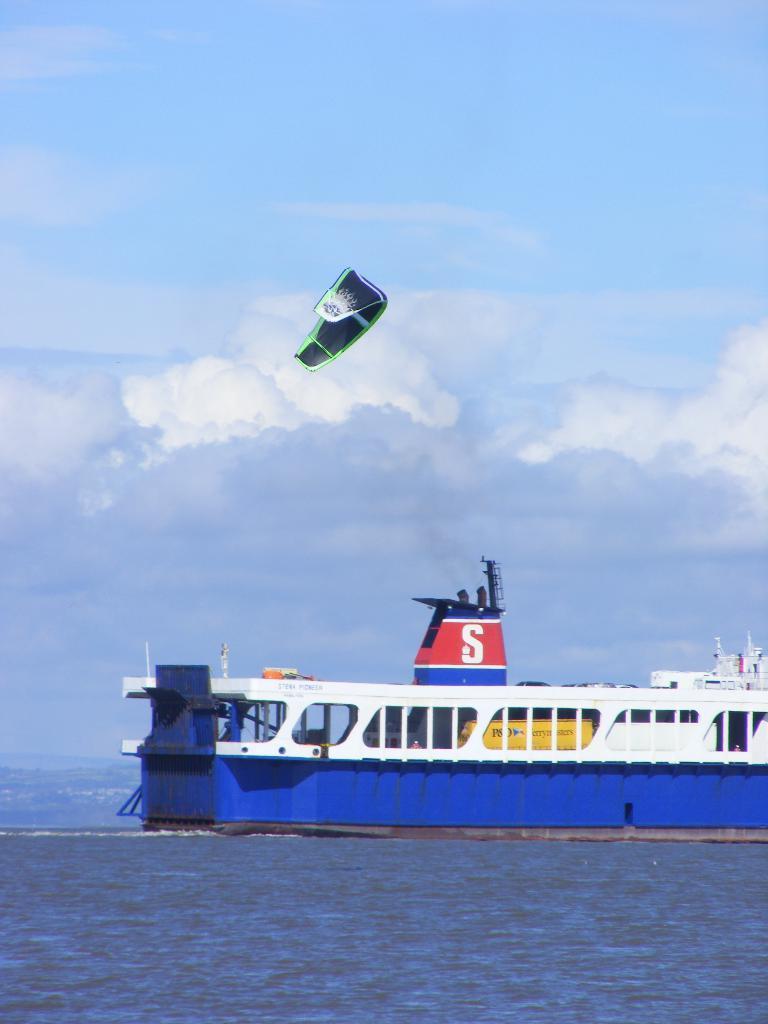Could you give a brief overview of what you see in this image? In this image there is a ship on the water , and in the background there is a parachute in the sky. 